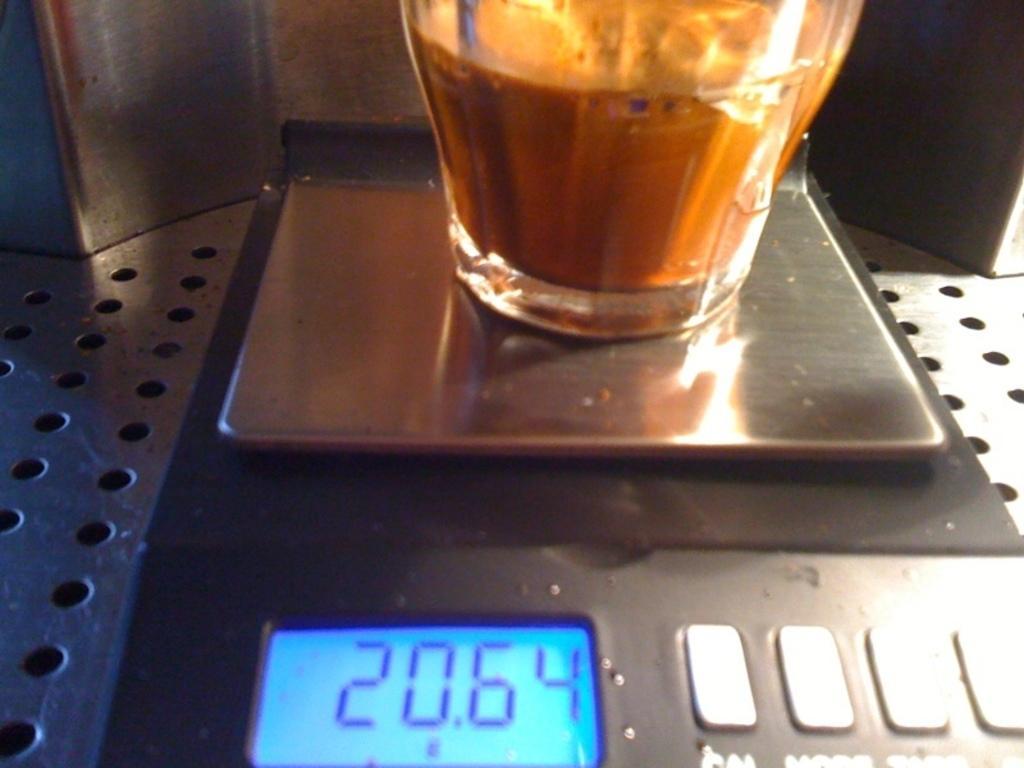How would you summarize this image in a sentence or two? In this picture, we see the espresso machine and a cup containing a coffee. At the bottom, we see the digital display which is displaying the digits. Beside that, we see the white color buttons. 